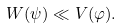<formula> <loc_0><loc_0><loc_500><loc_500>W ( \psi ) \ll V ( \varphi ) .</formula> 